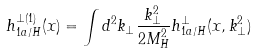Convert formula to latex. <formula><loc_0><loc_0><loc_500><loc_500>h _ { 1 a / H } ^ { \perp ( 1 ) } ( x ) = \int d ^ { 2 } k _ { \perp } \frac { k ^ { 2 } _ { \perp } } { 2 M ^ { 2 } _ { H } } h _ { 1 a / H } ^ { \perp } ( x , k ^ { 2 } _ { \perp } )</formula> 